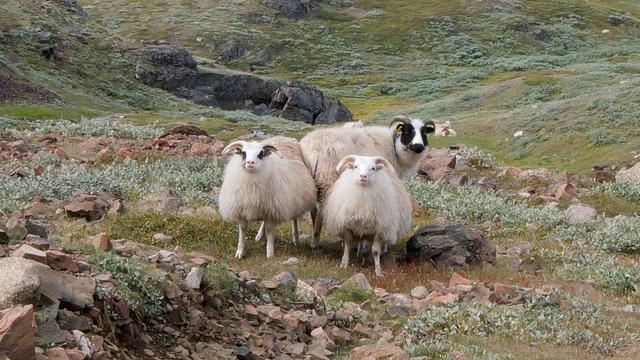What are these animals called?

Choices:
A) dogs
B) cows
C) sheep
D) deer sheep 